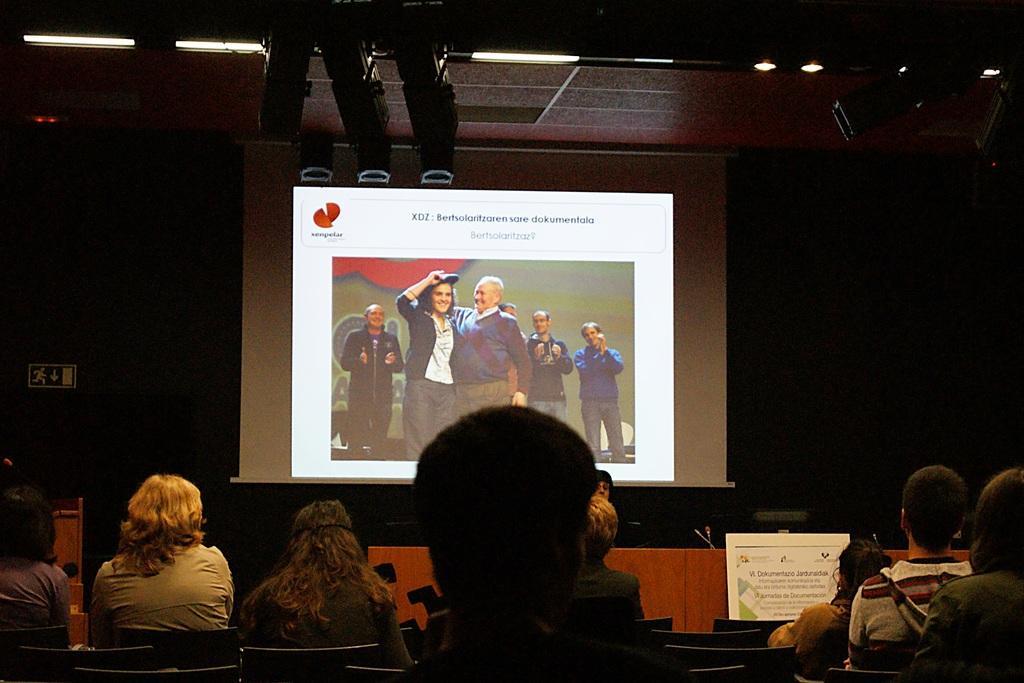How would you summarize this image in a sentence or two? In the foreground of this image, there is a person's head. In the background, there are persons sitting on the chairs, a screen, few lights to the ceiling and the dark background. 